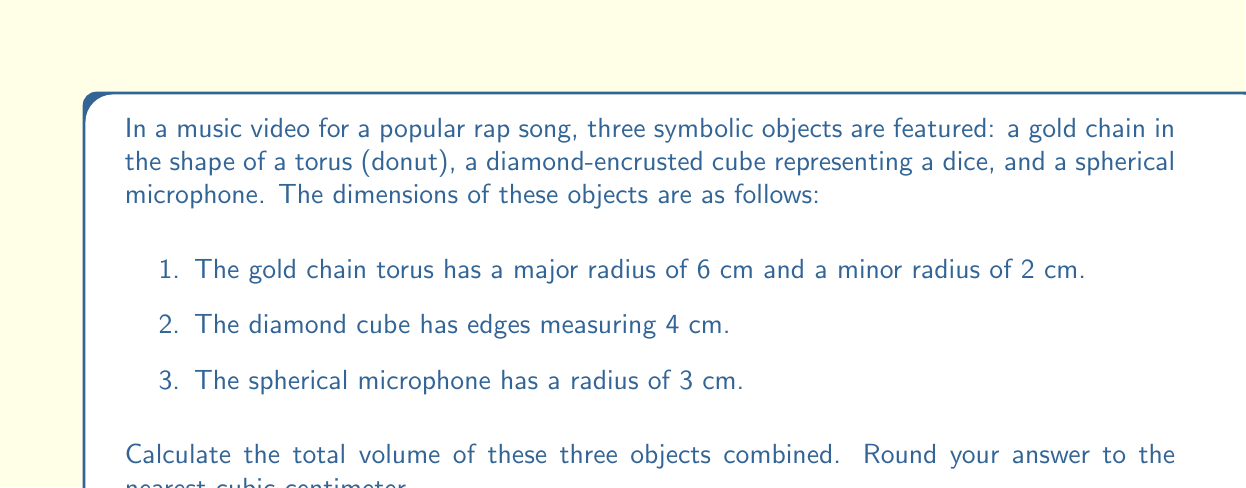Provide a solution to this math problem. To solve this problem, we need to calculate the volume of each object separately and then sum them up.

1. Volume of the torus (gold chain):
The formula for the volume of a torus is:
$$V_{torus} = 2\pi^2R r^2$$
Where $R$ is the major radius and $r$ is the minor radius.

Substituting the values:
$$V_{torus} = 2\pi^2 \cdot 6 \cdot 2^2 = 48\pi^2 \approx 473.85 \text{ cm}^3$$

2. Volume of the cube (diamond dice):
The formula for the volume of a cube is:
$$V_{cube} = s^3$$
Where $s$ is the length of an edge.

Substituting the value:
$$V_{cube} = 4^3 = 64 \text{ cm}^3$$

3. Volume of the sphere (microphone):
The formula for the volume of a sphere is:
$$V_{sphere} = \frac{4}{3}\pi r^3$$
Where $r$ is the radius of the sphere.

Substituting the value:
$$V_{sphere} = \frac{4}{3}\pi \cdot 3^3 = 36\pi \approx 113.10 \text{ cm}^3$$

Now, we sum up the volumes of all three objects:
$$V_{total} = V_{torus} + V_{cube} + V_{sphere}$$
$$V_{total} = 473.85 + 64 + 113.10 = 650.95 \text{ cm}^3$$

Rounding to the nearest cubic centimeter:
$$V_{total} \approx 651 \text{ cm}^3$$
Answer: 651 cm³ 